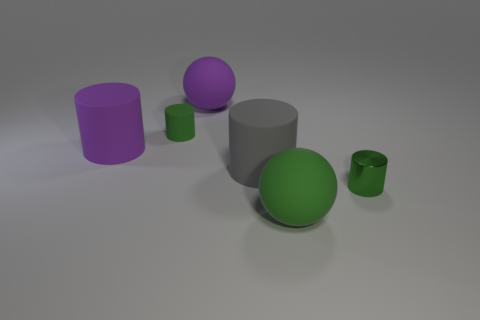What number of metallic cylinders have the same color as the shiny object?
Provide a short and direct response. 0. What number of things are either large gray cylinders or big blue shiny spheres?
Provide a succinct answer. 1. What shape is the green metallic object that is the same size as the green rubber cylinder?
Your response must be concise. Cylinder. How many cylinders are both to the right of the large gray object and behind the gray rubber thing?
Give a very brief answer. 0. What material is the green cylinder that is in front of the large gray cylinder?
Give a very brief answer. Metal. What is the size of the green cylinder that is the same material as the purple ball?
Keep it short and to the point. Small. There is a rubber ball in front of the purple cylinder; does it have the same size as the green rubber thing on the left side of the purple sphere?
Give a very brief answer. No. What material is the other green cylinder that is the same size as the green rubber cylinder?
Ensure brevity in your answer.  Metal. There is a green object that is both behind the green matte sphere and in front of the big purple matte cylinder; what is its material?
Your answer should be compact. Metal. Are any purple shiny objects visible?
Ensure brevity in your answer.  No. 